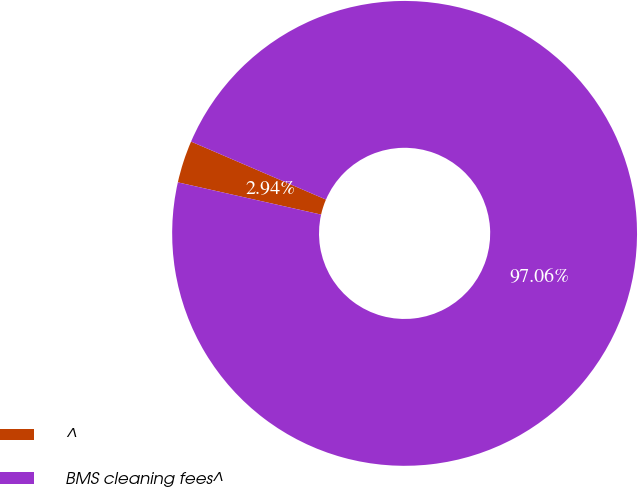<chart> <loc_0><loc_0><loc_500><loc_500><pie_chart><fcel>^<fcel>BMS cleaning fees^<nl><fcel>2.94%<fcel>97.06%<nl></chart> 